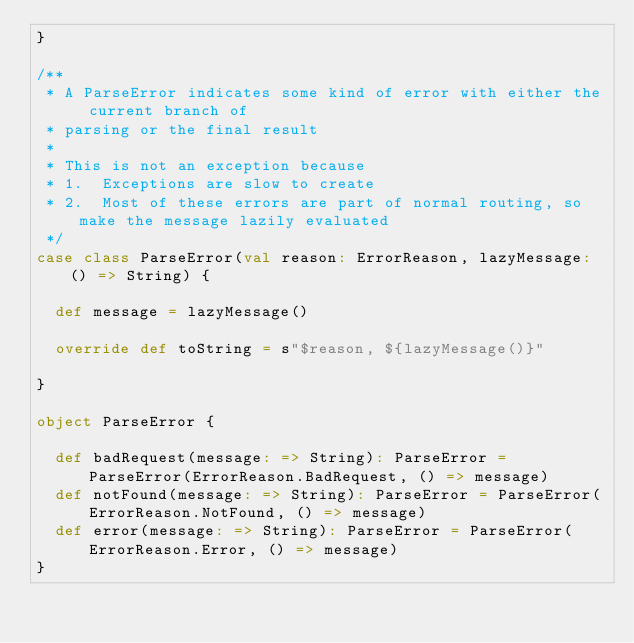Convert code to text. <code><loc_0><loc_0><loc_500><loc_500><_Scala_>}

/**
 * A ParseError indicates some kind of error with either the current branch of
 * parsing or the final result
 *
 * This is not an exception because
 * 1.  Exceptions are slow to create
 * 2.  Most of these errors are part of normal routing, so make the message lazily evaluated
 */
case class ParseError(val reason: ErrorReason, lazyMessage: () => String) {

  def message = lazyMessage()

  override def toString = s"$reason, ${lazyMessage()}"

}

object ParseError {

  def badRequest(message: => String): ParseError = ParseError(ErrorReason.BadRequest, () => message)
  def notFound(message: => String): ParseError = ParseError(ErrorReason.NotFound, () => message)
  def error(message: => String): ParseError = ParseError(ErrorReason.Error, () => message)
}
</code> 